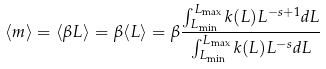<formula> <loc_0><loc_0><loc_500><loc_500>\langle m \rangle = \langle \beta L \rangle = \beta \langle L \rangle = \beta \frac { \int _ { L _ { \min } } ^ { L _ { \max } } k ( L ) L ^ { - s + 1 } d L } { \int _ { L _ { \min } } ^ { L _ { \max } } k ( L ) L ^ { - s } d L }</formula> 